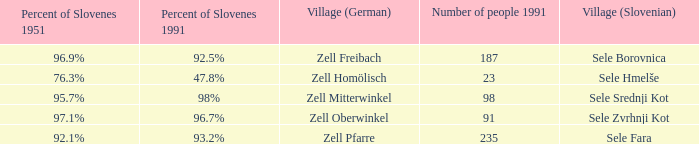Provide with the names of the village (German) that is part of village (Slovenian) with sele srednji kot. Zell Mitterwinkel. 